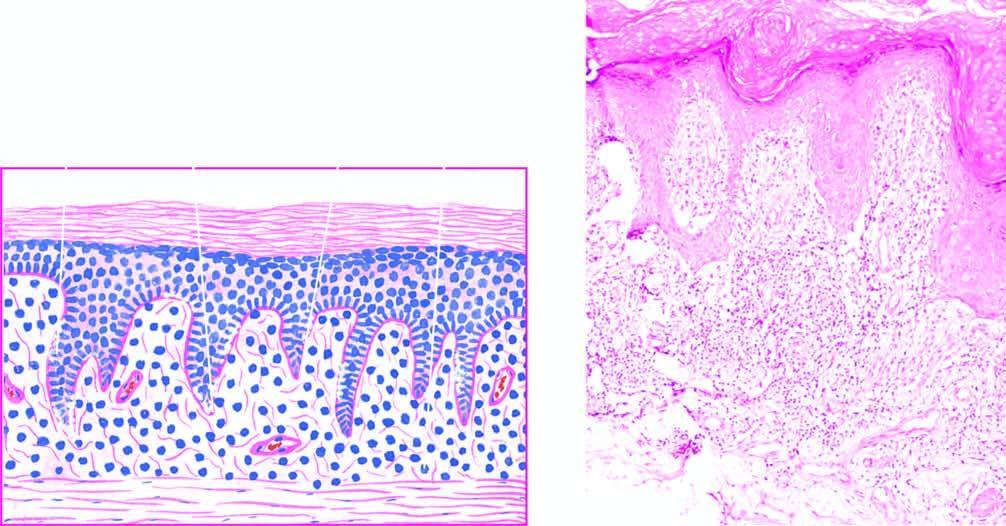does sectioned surface show liquefactive degeneration?
Answer the question using a single word or phrase. No 